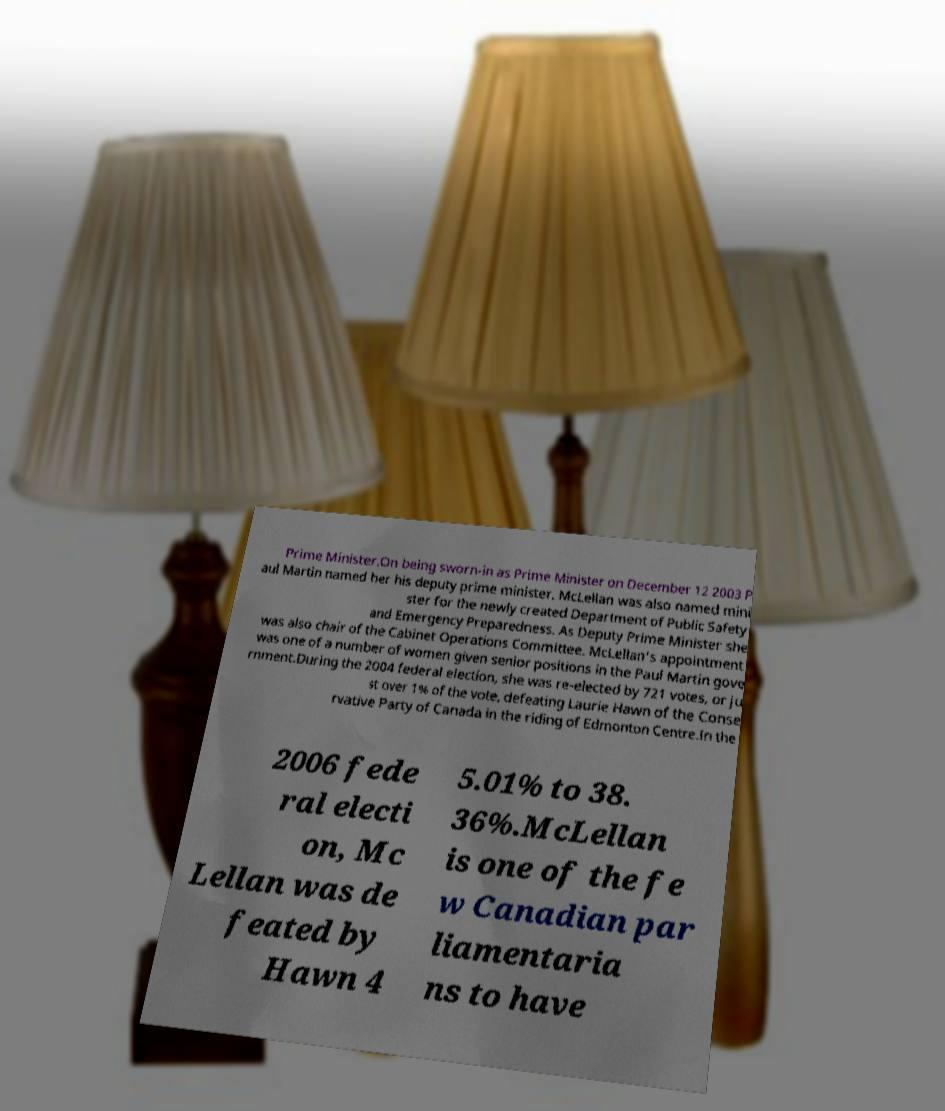For documentation purposes, I need the text within this image transcribed. Could you provide that? Prime Minister.On being sworn-in as Prime Minister on December 12 2003 P aul Martin named her his deputy prime minister. McLellan was also named mini ster for the newly created Department of Public Safety and Emergency Preparedness. As Deputy Prime Minister she was also chair of the Cabinet Operations Committee. McLellan's appointment was one of a number of women given senior positions in the Paul Martin gove rnment.During the 2004 federal election, she was re-elected by 721 votes, or ju st over 1% of the vote, defeating Laurie Hawn of the Conse rvative Party of Canada in the riding of Edmonton Centre.In the 2006 fede ral electi on, Mc Lellan was de feated by Hawn 4 5.01% to 38. 36%.McLellan is one of the fe w Canadian par liamentaria ns to have 